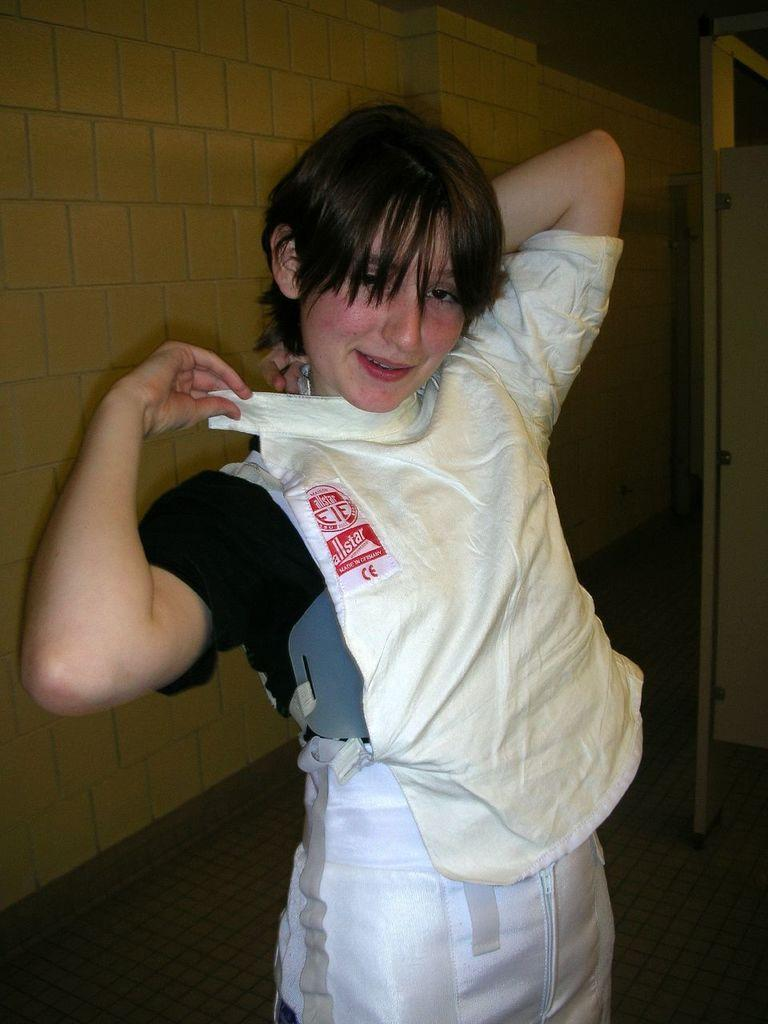Who is the main subject in the image? There is a woman in the image. What is the woman doing in the image? The woman is standing and posing for the picture. What is the woman wearing in the image? The woman is wearing a top. What can be seen behind the woman in the image? There is a wall behind the woman. How would you describe the lighting in the image? The background of the image is dark. What type of machine can be seen in the background of the image? There is no machine present in the background of the image. Is the woman standing near a cemetery in the image? There is no indication of a cemetery in the image; it only features a woman standing in front of a wall. 